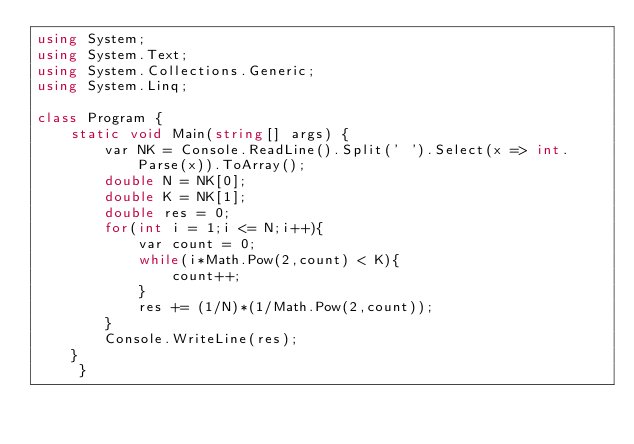Convert code to text. <code><loc_0><loc_0><loc_500><loc_500><_C#_>using System;
using System.Text;
using System.Collections.Generic;
using System.Linq;
 
class Program {
    static void Main(string[] args) {
        var NK = Console.ReadLine().Split(' ').Select(x => int.Parse(x)).ToArray();
        double N = NK[0];
        double K = NK[1];
        double res = 0;
        for(int i = 1;i <= N;i++){
            var count = 0;
            while(i*Math.Pow(2,count) < K){
                count++;
            }
            res += (1/N)*(1/Math.Pow(2,count));
        }
        Console.WriteLine(res);
    }             
     }
</code> 